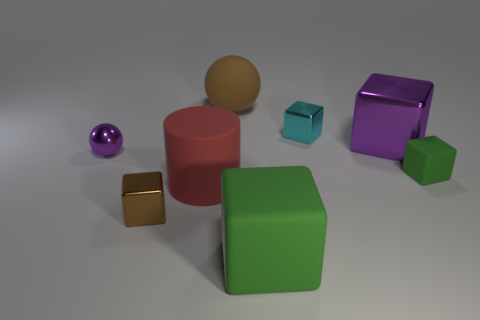How many big brown objects are the same shape as the red thing?
Your answer should be compact. 0. There is a green object to the left of the green block that is behind the brown thing that is in front of the big brown ball; how big is it?
Give a very brief answer. Large. Is the purple object in front of the large purple cube made of the same material as the purple block?
Keep it short and to the point. Yes. Are there an equal number of red things that are behind the large rubber cylinder and big matte balls that are in front of the tiny brown object?
Provide a short and direct response. Yes. What is the material of the purple thing that is the same shape as the tiny green object?
Ensure brevity in your answer.  Metal. Are there any big purple blocks that are on the right side of the green block that is to the right of the green object in front of the rubber cylinder?
Offer a very short reply. No. There is a metal thing that is in front of the large red cylinder; does it have the same shape as the cyan metal object that is behind the big shiny object?
Offer a very short reply. Yes. Are there more brown objects that are behind the purple metal sphere than purple shiny cylinders?
Your answer should be compact. Yes. What number of objects are either large red objects or large metallic cubes?
Your answer should be very brief. 2. The small shiny ball has what color?
Provide a succinct answer. Purple. 